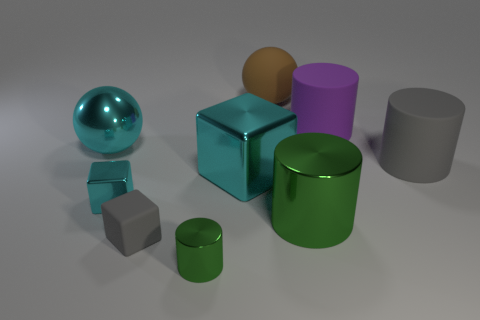Is the number of small cyan blocks that are in front of the tiny green metal thing less than the number of red balls?
Your answer should be very brief. No. What number of big gray objects are to the left of the tiny cyan shiny cube?
Provide a succinct answer. 0. Is the shape of the large matte thing that is in front of the big metallic sphere the same as the large cyan thing in front of the gray matte cylinder?
Keep it short and to the point. No. The thing that is in front of the large cyan cube and to the right of the brown object has what shape?
Give a very brief answer. Cylinder. There is a gray cube that is the same material as the big purple cylinder; what is its size?
Give a very brief answer. Small. Is the number of large purple matte things less than the number of big blue balls?
Your response must be concise. No. What is the material of the gray object that is on the right side of the green cylinder in front of the green metallic cylinder to the right of the small green cylinder?
Give a very brief answer. Rubber. Do the green object that is behind the small gray cube and the gray thing that is on the left side of the large brown ball have the same material?
Make the answer very short. No. There is a rubber object that is both on the left side of the purple object and in front of the brown sphere; what size is it?
Give a very brief answer. Small. There is a cube that is the same size as the cyan shiny sphere; what is it made of?
Provide a succinct answer. Metal. 